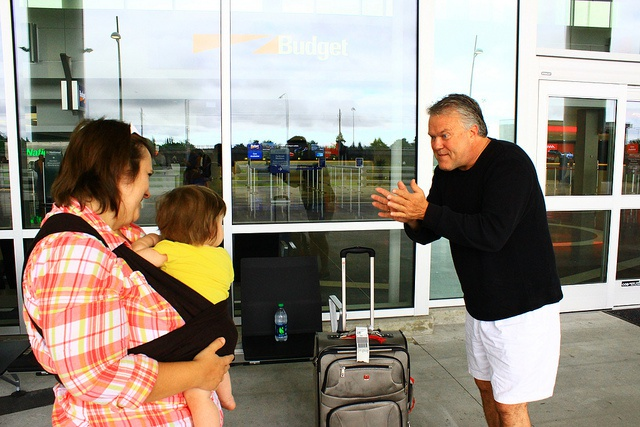Describe the objects in this image and their specific colors. I can see people in white, salmon, orange, and black tones, people in white, black, orange, and maroon tones, people in white, black, maroon, gold, and tan tones, suitcase in white, black, gray, and darkgray tones, and suitcase in white, black, gray, and blue tones in this image. 